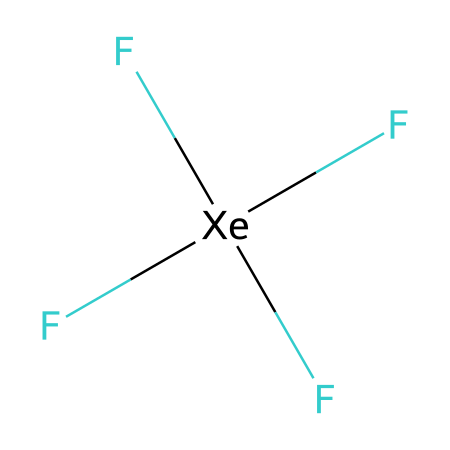How many fluorine atoms are present in xenon tetrafluoride? The structure shows four fluorine (F) atoms attached to the xenon (Xe) atom, which is indicated by four F labels in the SMILES representation.
Answer: four What is the total number of atoms in xenon tetrafluoride? The total number of atoms can be counted as one xenon atom (Xe) and four fluorine atoms (F), giving a total of five atoms.
Answer: five What type of bonding is implied by the presence of xenon in this compound? Xenon tetrafluoride shows that xenon can expand its valence shell to form bonds with multiple fluorine atoms, indicating it has hypervalent bonding characteristics.
Answer: hypervalent How many bonds are formed between xenon and fluorine in this compound? Each fluorine forms a single bond with the xenon atom, and since there are four fluorine atoms, there are four bonds in total.
Answer: four What geometrical shape does xenon tetrafluoride adopt? Due to the four equivalent F atoms around the Xe atom, this compound typically adopts a square planar geometry, consistent with its hypervalent nature.
Answer: square planar Is xenon tetrafluoride polar or nonpolar, and why? The strong electronegativity difference between fluorine and xenon, and the asymmetrical arrangement of the fluorine atoms leads to a net dipole moment, making the molecule polar.
Answer: polar 